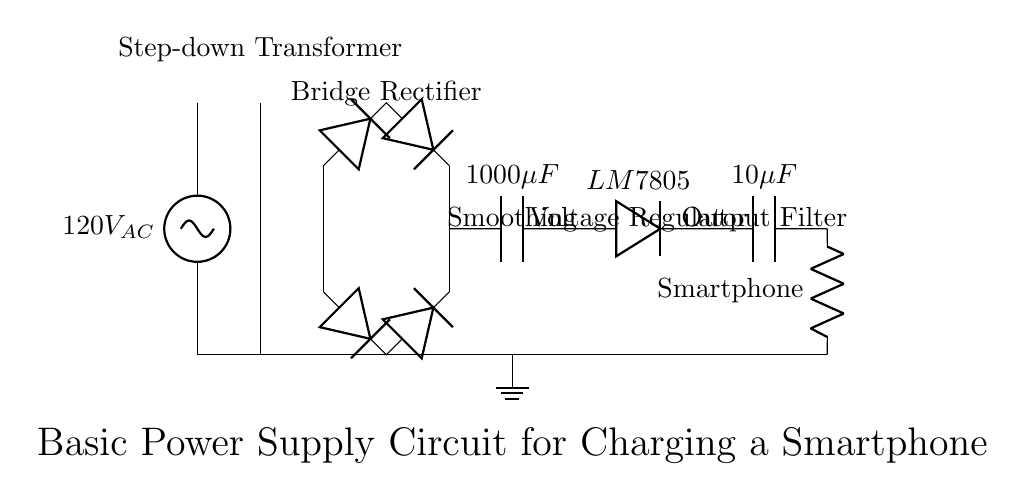What is the input voltage of the circuit? The circuit diagram indicates an AC power source supplying 120 volts, which is represented as 120V_AC.
Answer: 120V AC What type of rectifier is used in this circuit? A bridge rectifier is used, as shown by the configuration of four diodes arranged to convert AC to DC.
Answer: Bridge rectifier What is the capacitance value of the smoothing capacitor? The circuit diagram labels the smoothing capacitor with a capacitance value of 1000 microfarads, which helps in smoothing out the rectified voltage.
Answer: 1000 microfarads What is the output voltage of the voltage regulator? The LM7805 voltage regulator is responsible for regulating the output voltage to 5 volts, specifically designed for charging devices like smartphones.
Answer: 5 volts Why is there an output capacitor in the circuit? The output capacitor, specified as 10 microfarads, is used to further filter and stabilize the voltage provided to the load (smartphone) by reducing voltage ripple.
Answer: To reduce ripple What is the load connected at the end of the circuit? The load in this circuit is labeled as "Smartphone," indicating that this power supply is intended to charge a smartphone device.
Answer: Smartphone 